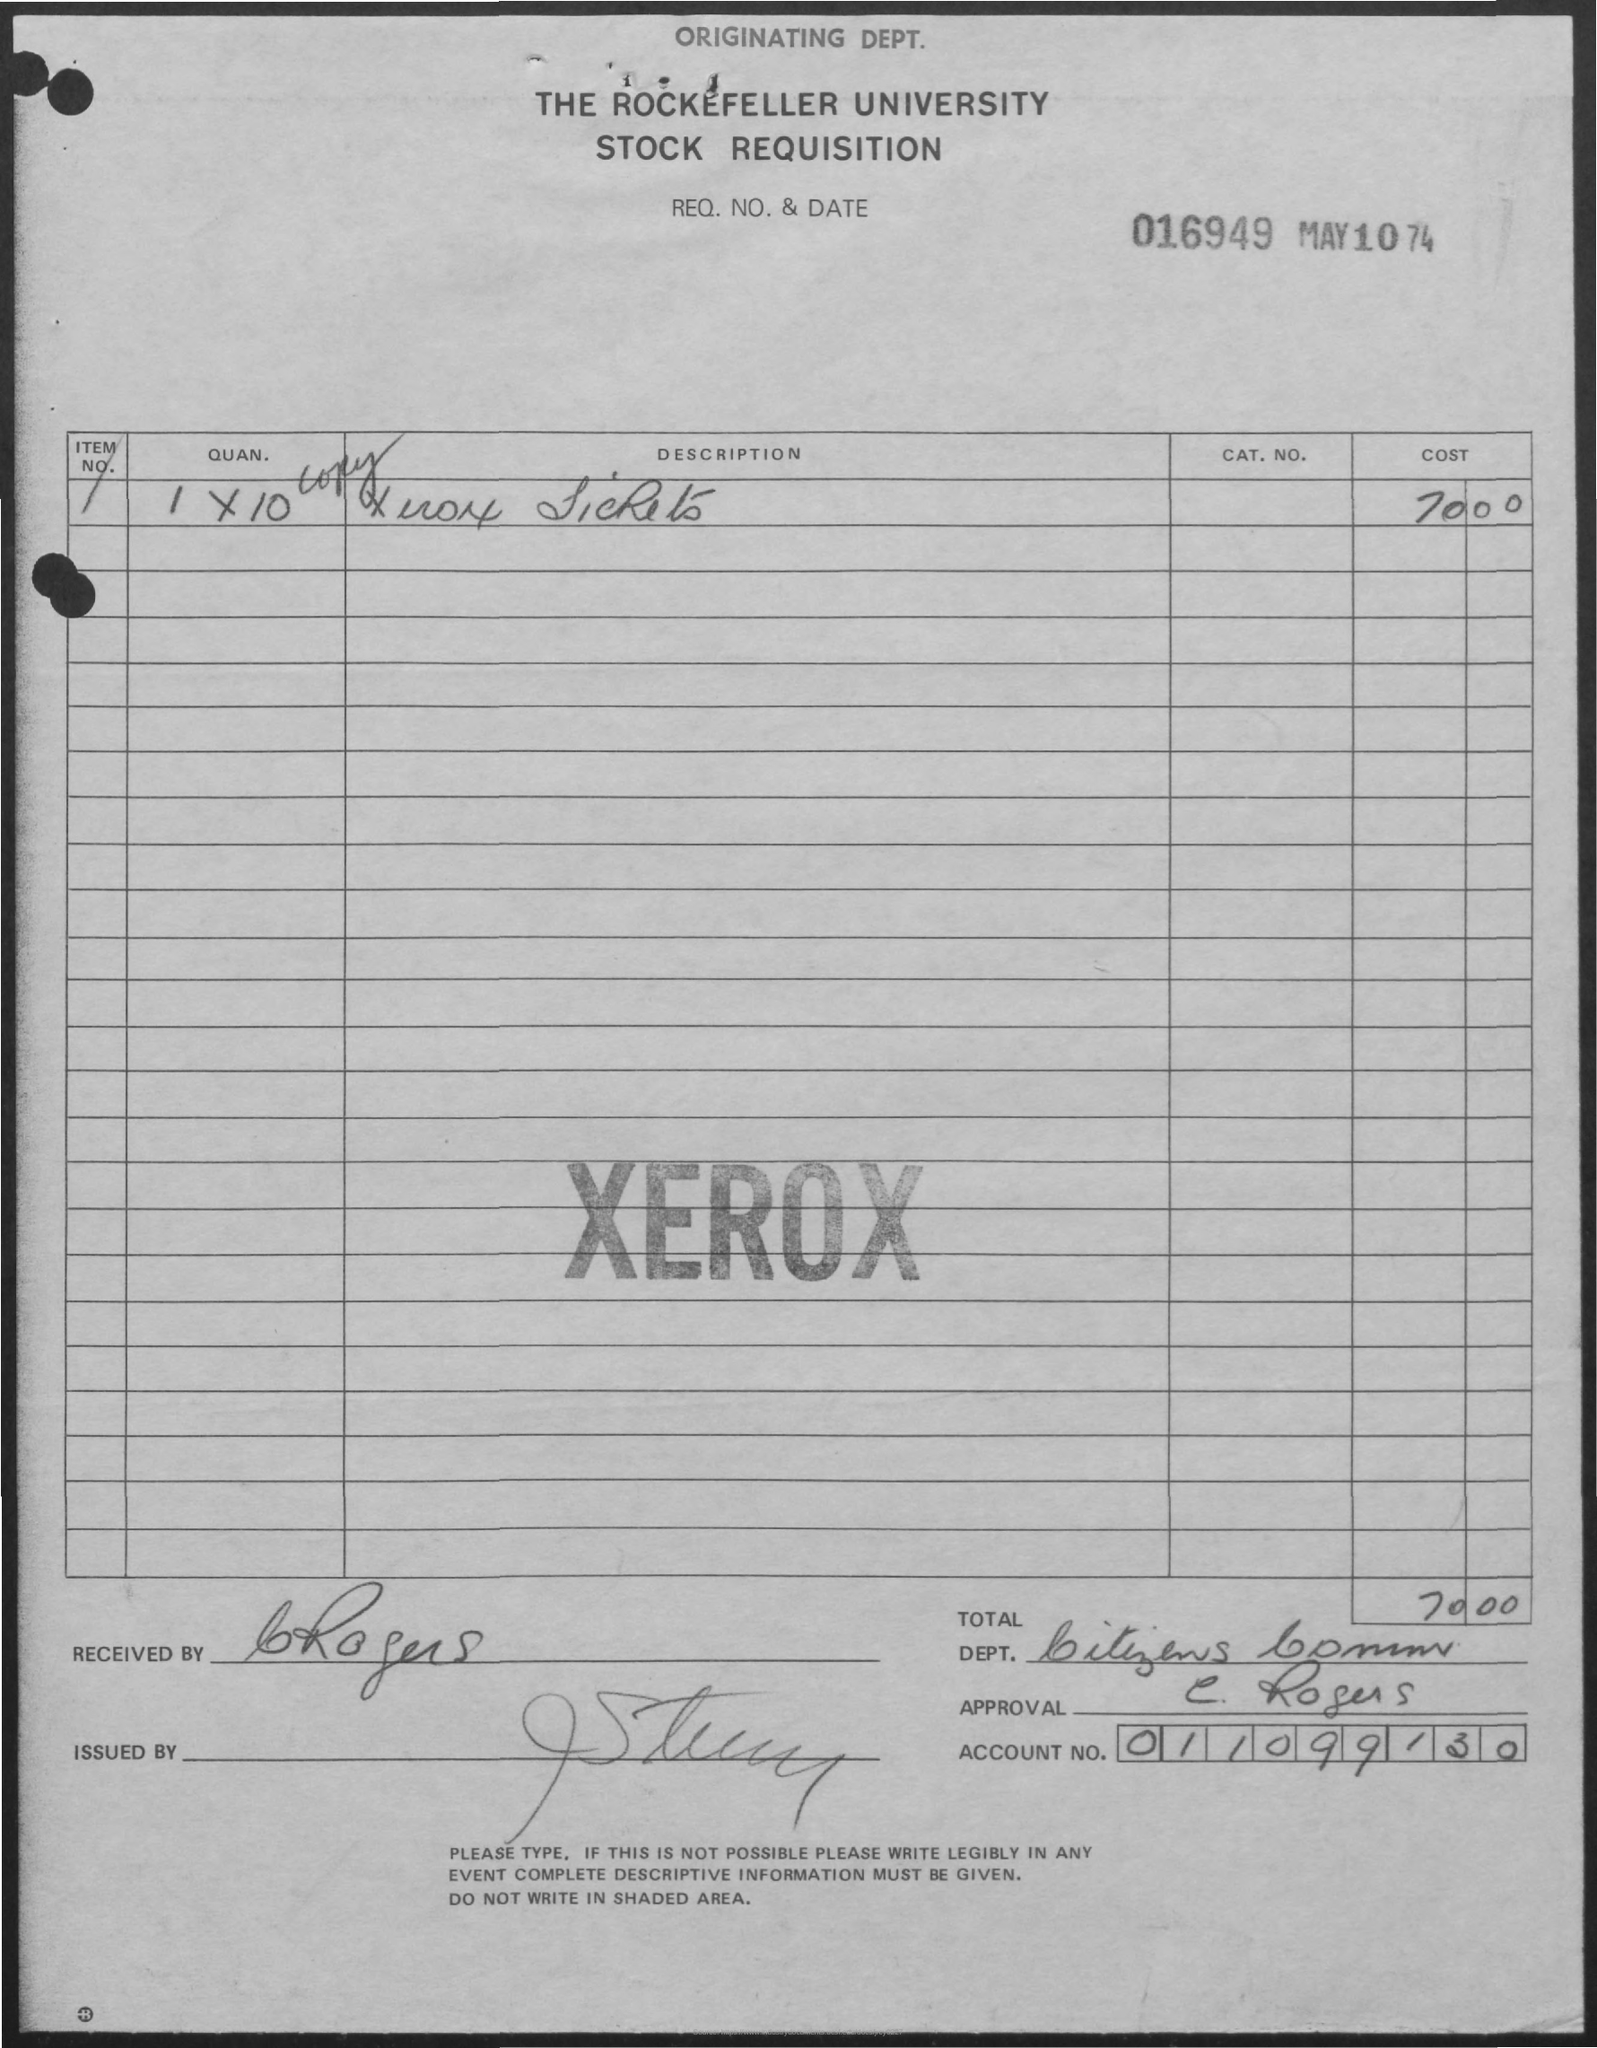Highlight a few significant elements in this photo. The first title in the document is 'Originating Dept.' I request that you provide me with Req. No. 016949 from May 10, 1974. The text in bold letters at the center of this document, which appears to be a stamp, is XEROX. The account number is 011099130. The total is 70.00 dollars. 